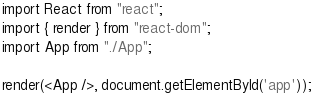Convert code to text. <code><loc_0><loc_0><loc_500><loc_500><_JavaScript_>import React from "react";
import { render } from "react-dom";
import App from "./App";

render(<App />, document.getElementById('app'));
</code> 